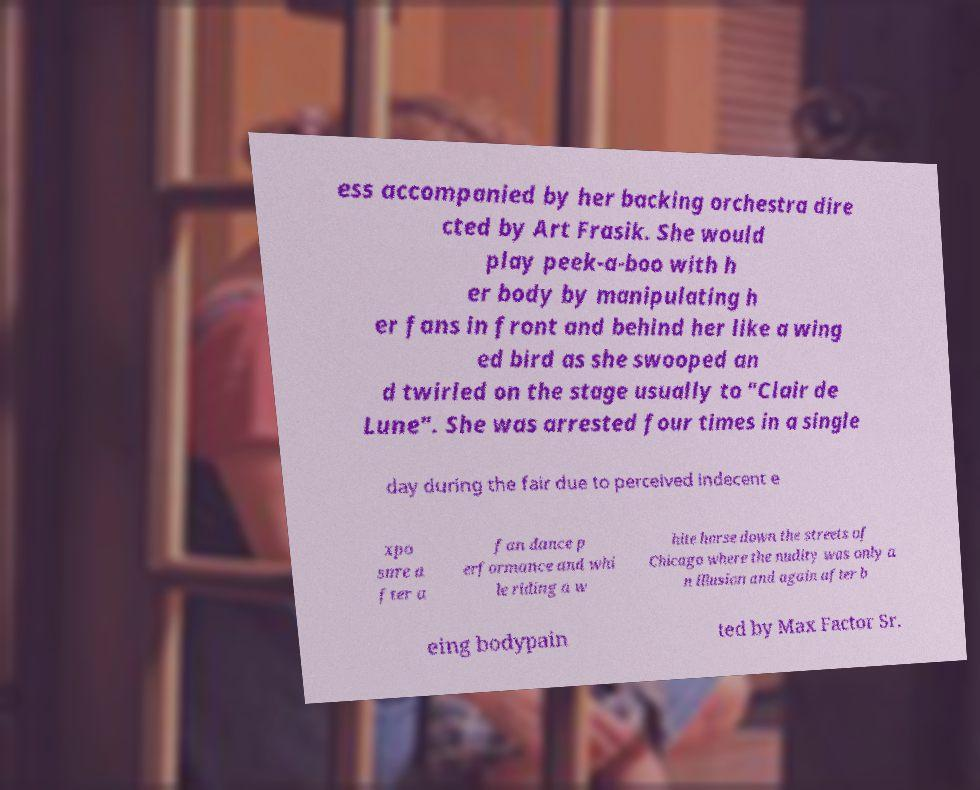Please read and relay the text visible in this image. What does it say? ess accompanied by her backing orchestra dire cted by Art Frasik. She would play peek-a-boo with h er body by manipulating h er fans in front and behind her like a wing ed bird as she swooped an d twirled on the stage usually to "Clair de Lune". She was arrested four times in a single day during the fair due to perceived indecent e xpo sure a fter a fan dance p erformance and whi le riding a w hite horse down the streets of Chicago where the nudity was only a n illusion and again after b eing bodypain ted by Max Factor Sr. 